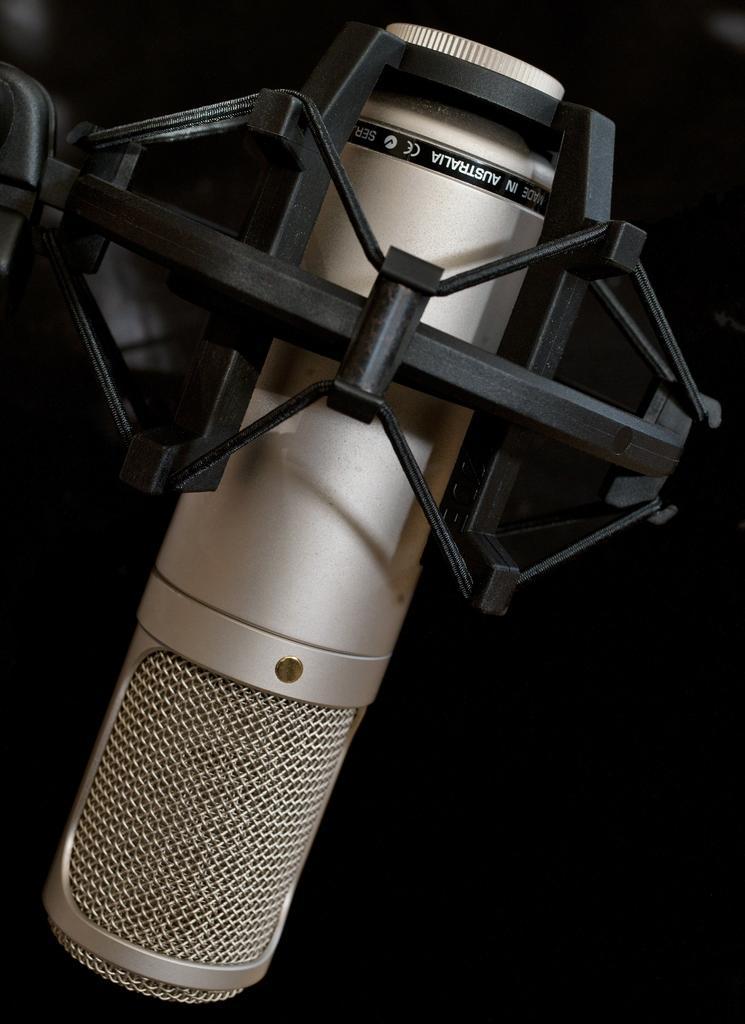Please provide a concise description of this image. In this image I can see the mike which is fixed to the stand. 